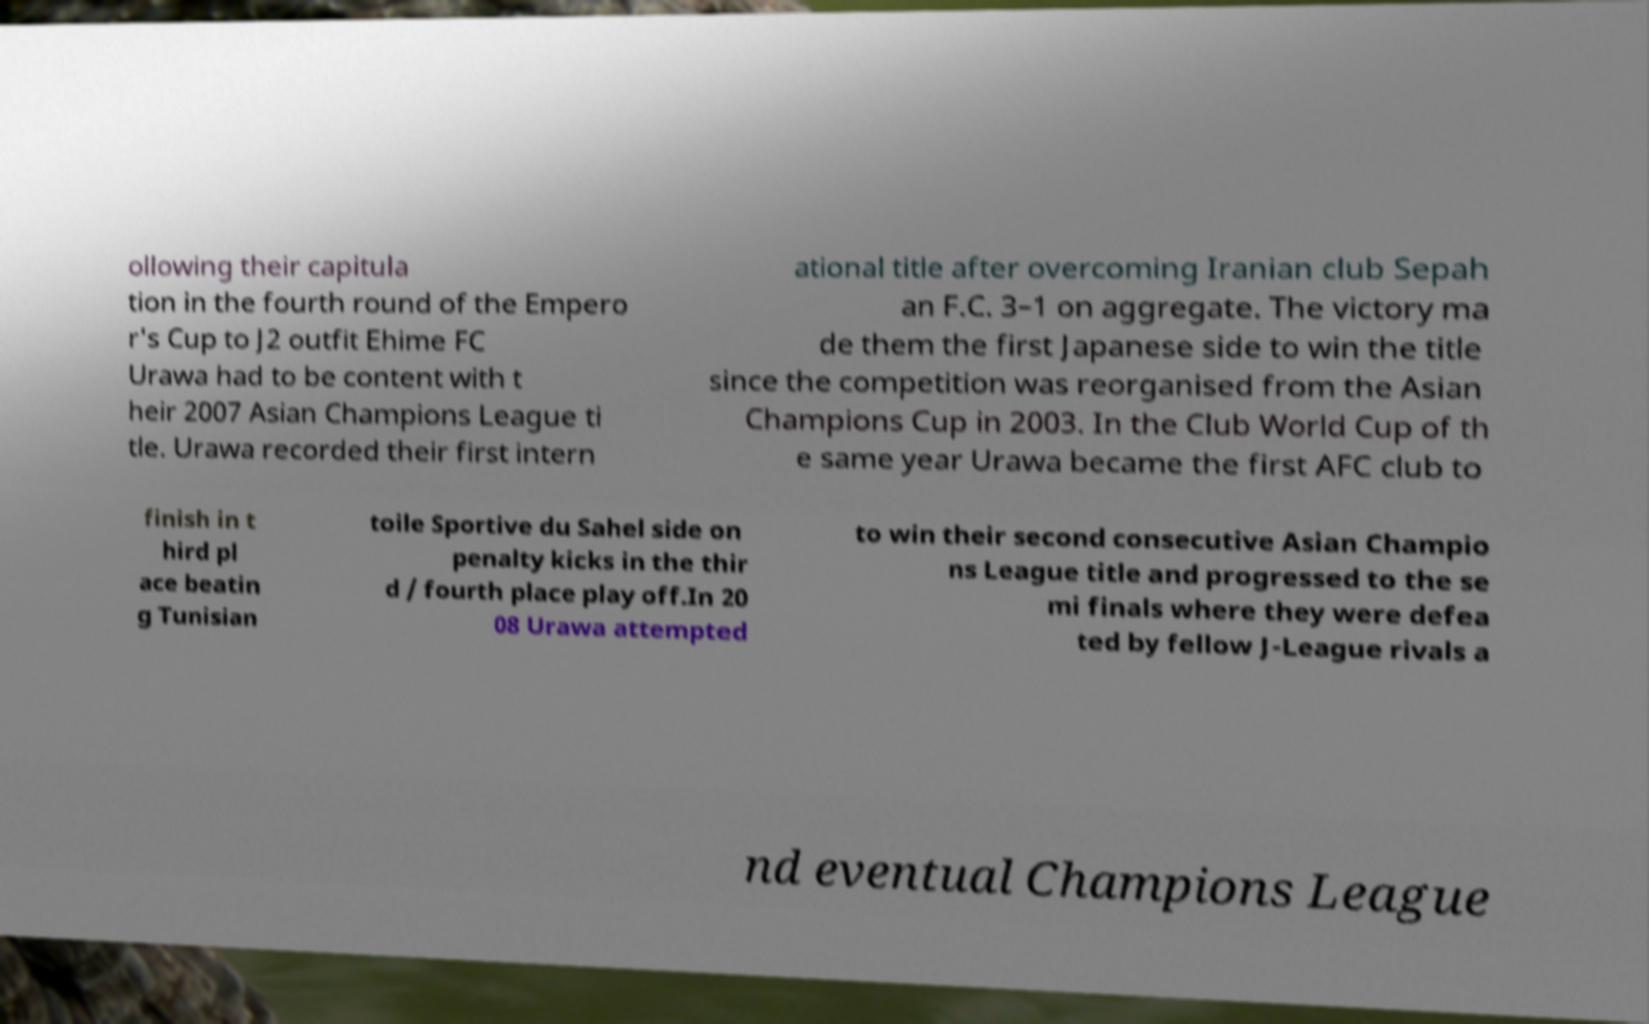For documentation purposes, I need the text within this image transcribed. Could you provide that? ollowing their capitula tion in the fourth round of the Empero r's Cup to J2 outfit Ehime FC Urawa had to be content with t heir 2007 Asian Champions League ti tle. Urawa recorded their first intern ational title after overcoming Iranian club Sepah an F.C. 3–1 on aggregate. The victory ma de them the first Japanese side to win the title since the competition was reorganised from the Asian Champions Cup in 2003. In the Club World Cup of th e same year Urawa became the first AFC club to finish in t hird pl ace beatin g Tunisian toile Sportive du Sahel side on penalty kicks in the thir d / fourth place play off.In 20 08 Urawa attempted to win their second consecutive Asian Champio ns League title and progressed to the se mi finals where they were defea ted by fellow J-League rivals a nd eventual Champions League 